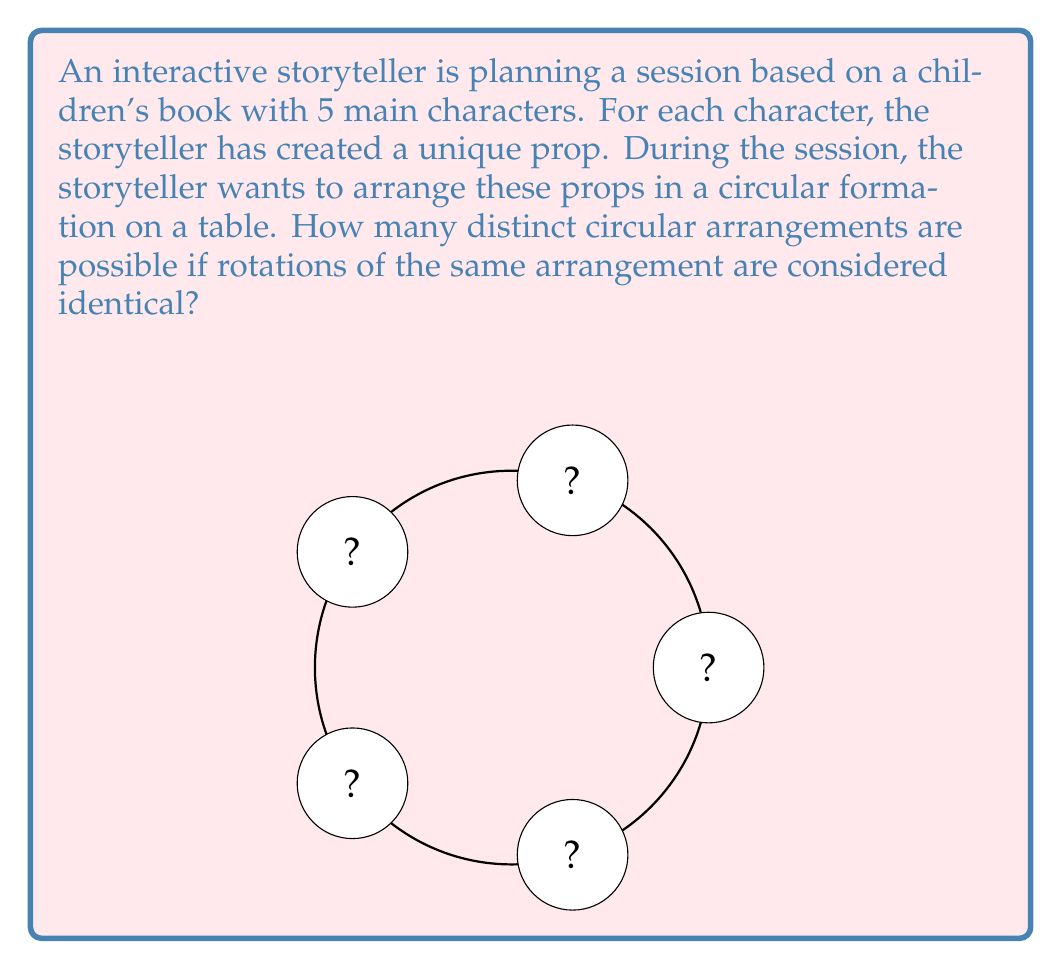Show me your answer to this math problem. Let's approach this step-by-step using group theory concepts:

1) First, we need to recognize that this is a problem of circular permutations. In a circular arrangement, rotations of the same arrangement are considered identical.

2) The total number of linear permutations of 5 objects is 5! = 120.

3) However, in a circular arrangement, each linear permutation can be rotated 5 ways to produce the same circular arrangement. This is because we can start reading the circular arrangement from any of the 5 positions.

4) In group theory terms, we're looking at the orbit of each arrangement under the action of the cyclic group $C_5$ (rotations by multiples of 72°).

5) The orbit-stabilizer theorem tells us that the number of distinct orbits (unique circular arrangements) is equal to the total number of elements in the set (linear permutations) divided by the size of the group acting on it (number of rotations).

6) Mathematically, this can be expressed as:

   $$\text{Number of distinct circular arrangements} = \frac{5!}{5} = \frac{120}{5} = 24$$

7) This result can also be derived from the formula for circular permutations: $(n-1)!$ where $n$ is the number of objects.

   $$(5-1)! = 4! = 24$$

Thus, there are 24 distinct circular arrangements possible.
Answer: 24 